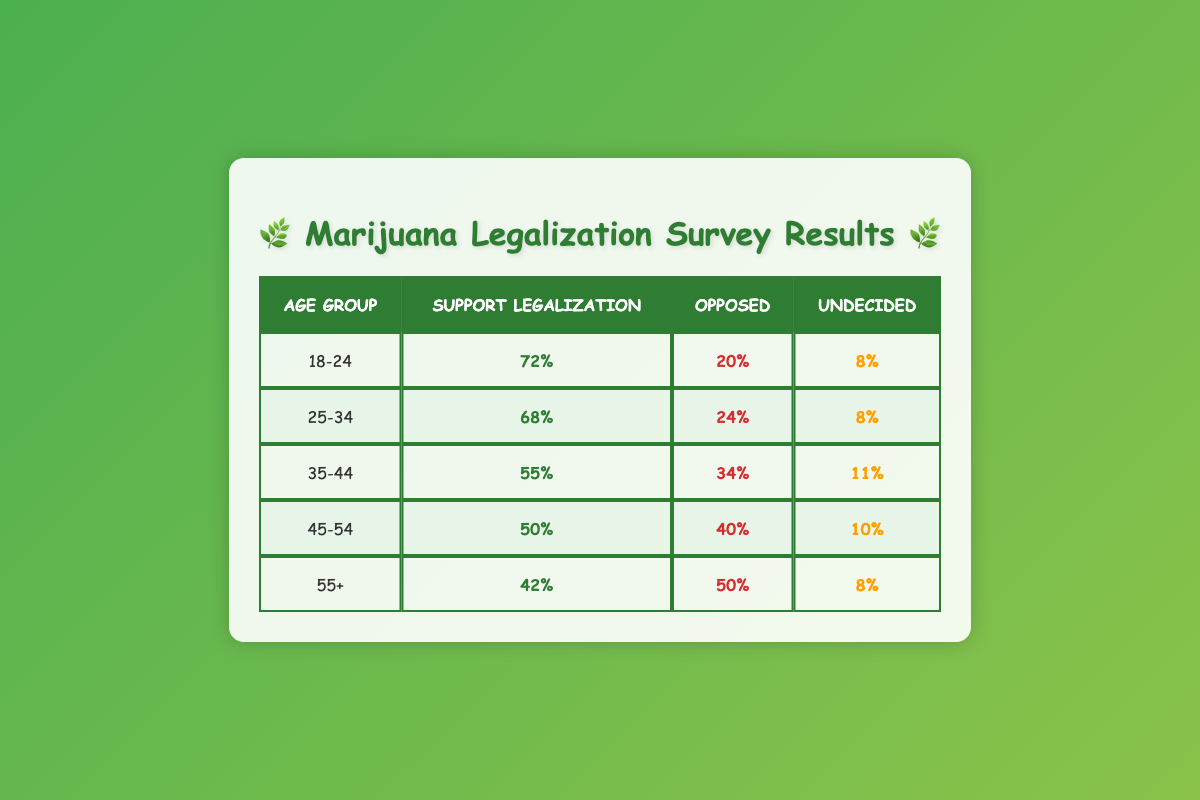What percentage of the 18-24 age group supports legalization? The table shows that the percentage of the 18-24 age group that supports marijuana legalization is 72% as reflected in the relevant cell under "Support Legalization" for that age group.
Answer: 72% Which age group has the highest percentage of opposition to legalization? Observing the "Opposed" column, the age group of 55+ has the highest percentage of opposition at 50%, as it is the largest value in that column compared to the others.
Answer: 55+ What is the average percentage support for legalization across all age groups? To find the average support, we sum the percentages of support: (72 + 68 + 55 + 50 + 42) = 287. There are 5 age groups, so we divide 287 by 5, yielding an average of 57.4%.
Answer: 57.4% Is the percentage of opposition greater than the percentage of support for the 45-54 age group? In the table, the "Opposed" percentage for the 45-54 age group is 40%, which is greater than the "Support Legalization" percentage of 50%. Therefore, the answer is no, the opposition is not greater.
Answer: No How many age groups have a support percentage lower than 60%? By checking the "Support Legalization" column, we see that the age groups 35-44 (55%), 45-54 (50%), and 55+ (42%) have support percentages lower than 60%. Thus, there are 3 age groups with lower support.
Answer: 3 What is the difference in support percentage between the 18-24 and 55+ age groups? The support percentage for the 18-24 age group is 72% and for the 55+ age group it is 42%. The difference is calculated by subtracting the lower percentage from the higher: 72% - 42% = 30%.
Answer: 30% Are there more undecided individuals in the 35-44 age group than in the 25-34 age group? The "Undecided" percentage for the 35-44 age group is 11%, while for the 25-34 age group it is 8%. Since 11% is greater than 8%, the answer is yes, there are more undecided individuals in the 35-44 age group.
Answer: Yes Which age group shows the least support for legalization? Looking at the "Support Legalization" percentages, the 55+ age group has the lowest support at 42%, making it the group with the least support for legalization among all age groups.
Answer: 55+ 